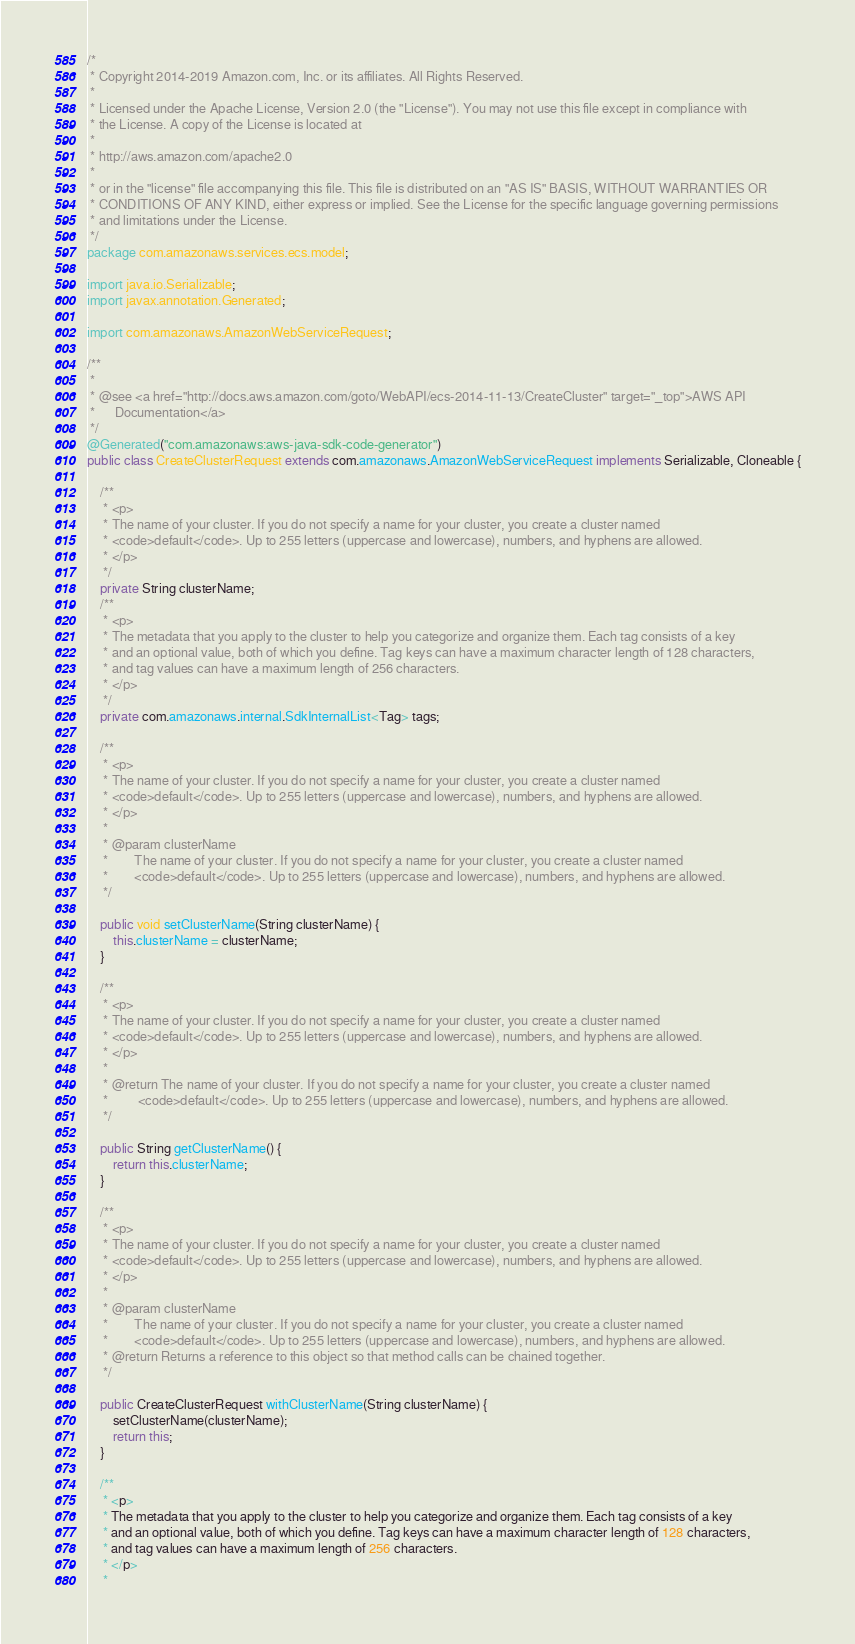Convert code to text. <code><loc_0><loc_0><loc_500><loc_500><_Java_>/*
 * Copyright 2014-2019 Amazon.com, Inc. or its affiliates. All Rights Reserved.
 * 
 * Licensed under the Apache License, Version 2.0 (the "License"). You may not use this file except in compliance with
 * the License. A copy of the License is located at
 * 
 * http://aws.amazon.com/apache2.0
 * 
 * or in the "license" file accompanying this file. This file is distributed on an "AS IS" BASIS, WITHOUT WARRANTIES OR
 * CONDITIONS OF ANY KIND, either express or implied. See the License for the specific language governing permissions
 * and limitations under the License.
 */
package com.amazonaws.services.ecs.model;

import java.io.Serializable;
import javax.annotation.Generated;

import com.amazonaws.AmazonWebServiceRequest;

/**
 * 
 * @see <a href="http://docs.aws.amazon.com/goto/WebAPI/ecs-2014-11-13/CreateCluster" target="_top">AWS API
 *      Documentation</a>
 */
@Generated("com.amazonaws:aws-java-sdk-code-generator")
public class CreateClusterRequest extends com.amazonaws.AmazonWebServiceRequest implements Serializable, Cloneable {

    /**
     * <p>
     * The name of your cluster. If you do not specify a name for your cluster, you create a cluster named
     * <code>default</code>. Up to 255 letters (uppercase and lowercase), numbers, and hyphens are allowed.
     * </p>
     */
    private String clusterName;
    /**
     * <p>
     * The metadata that you apply to the cluster to help you categorize and organize them. Each tag consists of a key
     * and an optional value, both of which you define. Tag keys can have a maximum character length of 128 characters,
     * and tag values can have a maximum length of 256 characters.
     * </p>
     */
    private com.amazonaws.internal.SdkInternalList<Tag> tags;

    /**
     * <p>
     * The name of your cluster. If you do not specify a name for your cluster, you create a cluster named
     * <code>default</code>. Up to 255 letters (uppercase and lowercase), numbers, and hyphens are allowed.
     * </p>
     * 
     * @param clusterName
     *        The name of your cluster. If you do not specify a name for your cluster, you create a cluster named
     *        <code>default</code>. Up to 255 letters (uppercase and lowercase), numbers, and hyphens are allowed.
     */

    public void setClusterName(String clusterName) {
        this.clusterName = clusterName;
    }

    /**
     * <p>
     * The name of your cluster. If you do not specify a name for your cluster, you create a cluster named
     * <code>default</code>. Up to 255 letters (uppercase and lowercase), numbers, and hyphens are allowed.
     * </p>
     * 
     * @return The name of your cluster. If you do not specify a name for your cluster, you create a cluster named
     *         <code>default</code>. Up to 255 letters (uppercase and lowercase), numbers, and hyphens are allowed.
     */

    public String getClusterName() {
        return this.clusterName;
    }

    /**
     * <p>
     * The name of your cluster. If you do not specify a name for your cluster, you create a cluster named
     * <code>default</code>. Up to 255 letters (uppercase and lowercase), numbers, and hyphens are allowed.
     * </p>
     * 
     * @param clusterName
     *        The name of your cluster. If you do not specify a name for your cluster, you create a cluster named
     *        <code>default</code>. Up to 255 letters (uppercase and lowercase), numbers, and hyphens are allowed.
     * @return Returns a reference to this object so that method calls can be chained together.
     */

    public CreateClusterRequest withClusterName(String clusterName) {
        setClusterName(clusterName);
        return this;
    }

    /**
     * <p>
     * The metadata that you apply to the cluster to help you categorize and organize them. Each tag consists of a key
     * and an optional value, both of which you define. Tag keys can have a maximum character length of 128 characters,
     * and tag values can have a maximum length of 256 characters.
     * </p>
     * </code> 